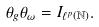Convert formula to latex. <formula><loc_0><loc_0><loc_500><loc_500>\theta _ { g } \theta _ { \omega } = I _ { \ell ^ { p } ( \mathbb { N } ) } .</formula> 